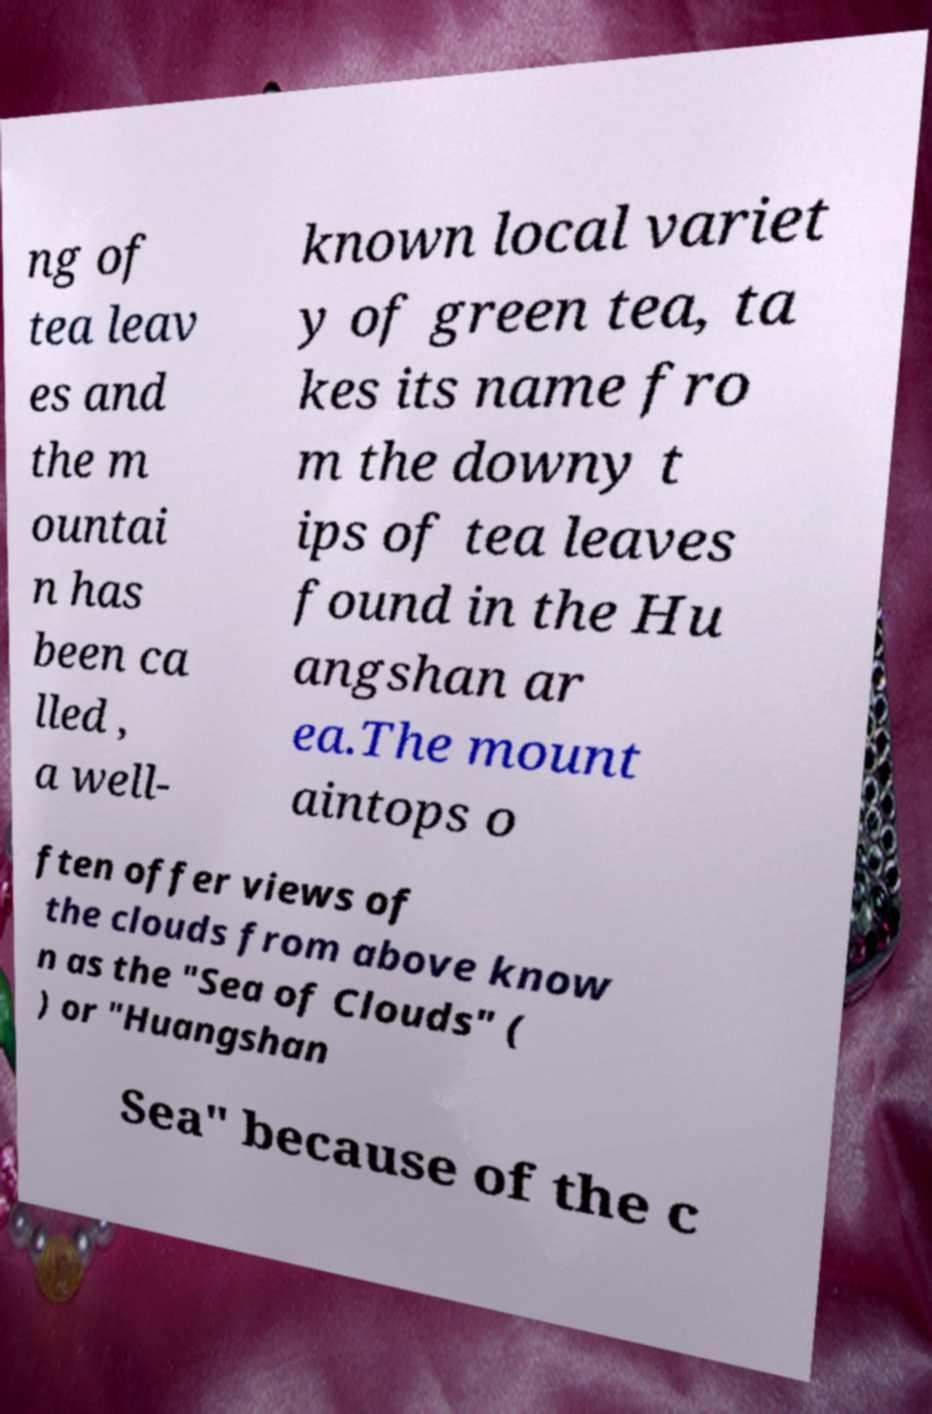Can you read and provide the text displayed in the image?This photo seems to have some interesting text. Can you extract and type it out for me? ng of tea leav es and the m ountai n has been ca lled , a well- known local variet y of green tea, ta kes its name fro m the downy t ips of tea leaves found in the Hu angshan ar ea.The mount aintops o ften offer views of the clouds from above know n as the "Sea of Clouds" ( ) or "Huangshan Sea" because of the c 